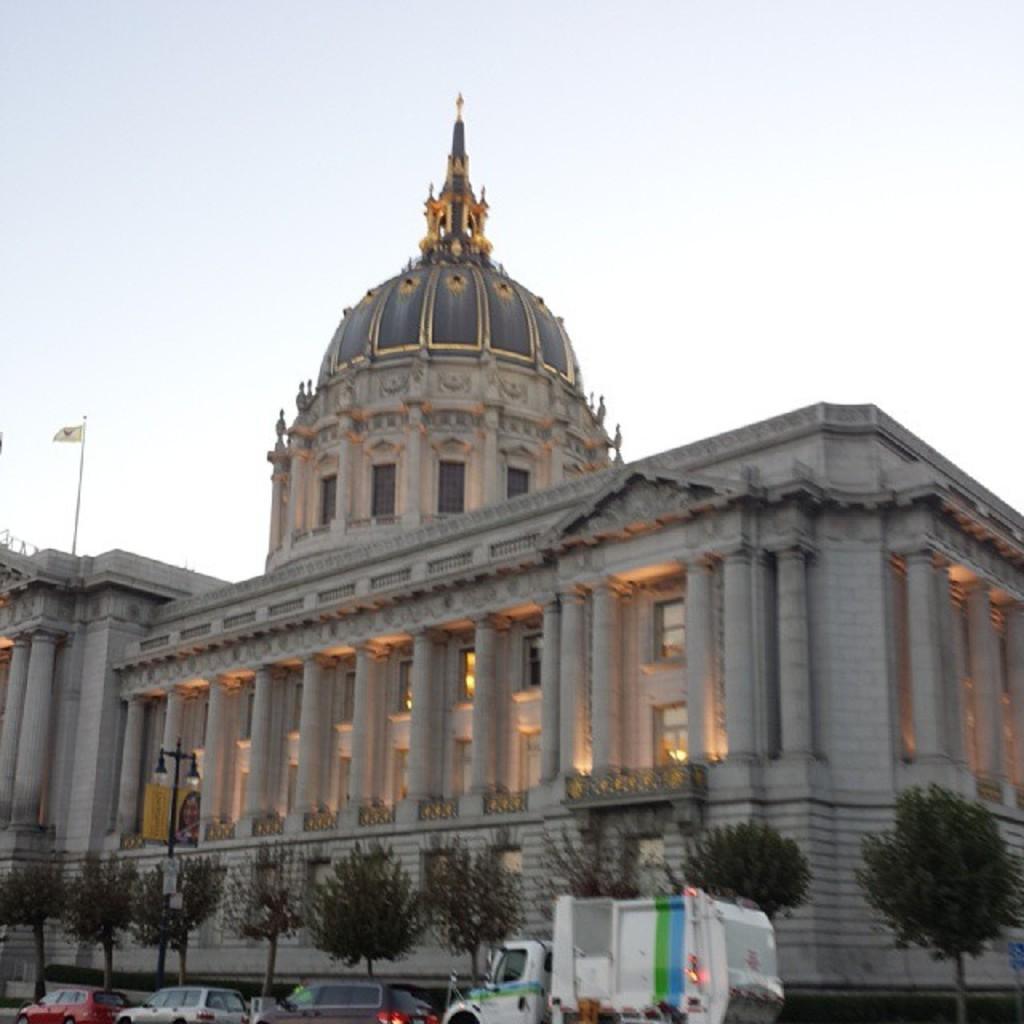Please provide a concise description of this image. Here in this picture we can see San Francisco City Hall present over there and in the front we can see cars and truck present on the road and we can also see trees and lamp posts present and on the left side we can see a flag post present on the top of it over there. 